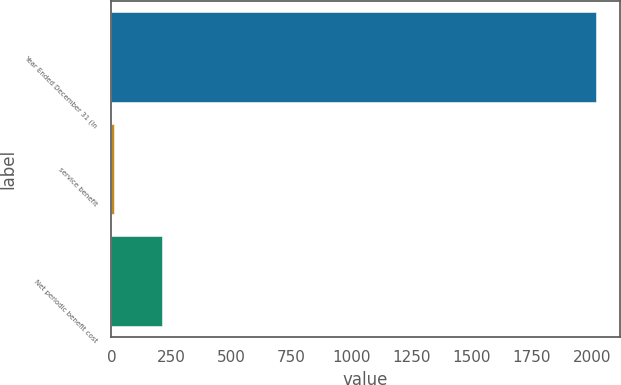Convert chart. <chart><loc_0><loc_0><loc_500><loc_500><bar_chart><fcel>Year Ended December 31 (In<fcel>service benefit<fcel>Net periodic benefit cost<nl><fcel>2015<fcel>10<fcel>210.5<nl></chart> 